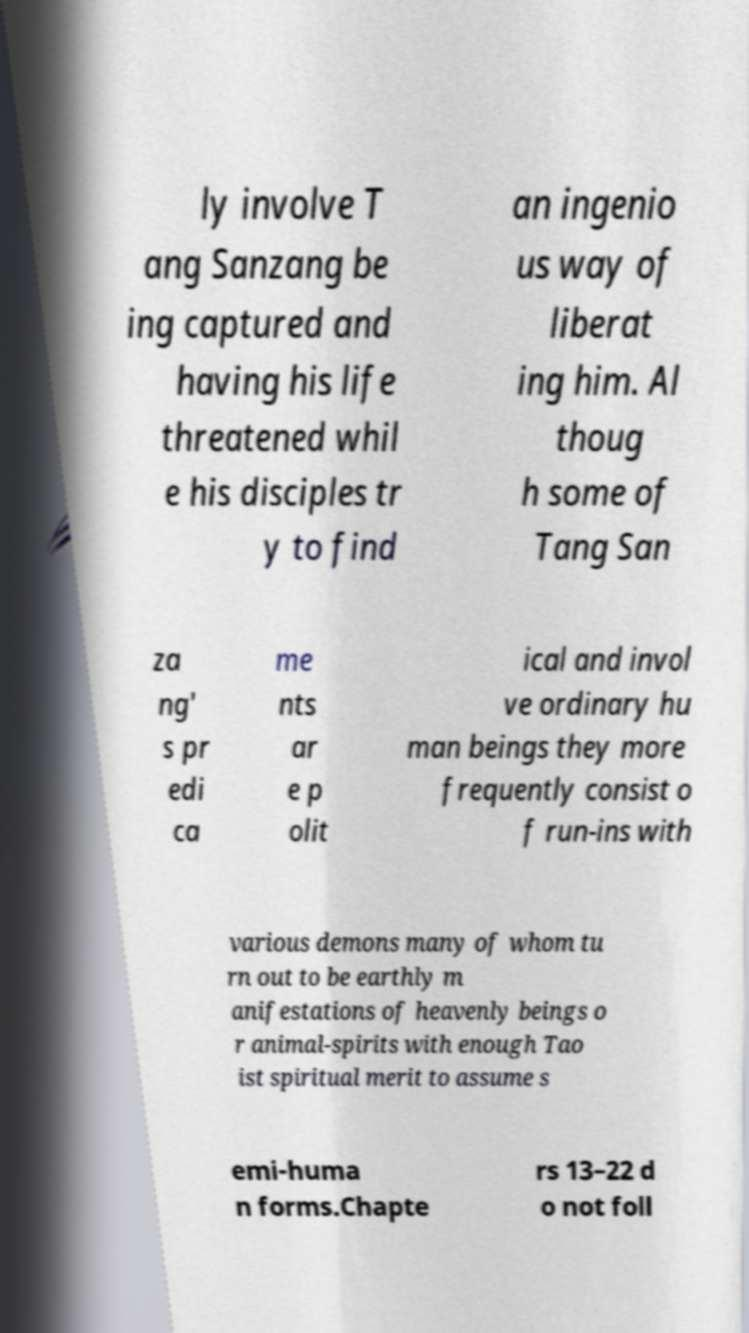Could you assist in decoding the text presented in this image and type it out clearly? ly involve T ang Sanzang be ing captured and having his life threatened whil e his disciples tr y to find an ingenio us way of liberat ing him. Al thoug h some of Tang San za ng' s pr edi ca me nts ar e p olit ical and invol ve ordinary hu man beings they more frequently consist o f run-ins with various demons many of whom tu rn out to be earthly m anifestations of heavenly beings o r animal-spirits with enough Tao ist spiritual merit to assume s emi-huma n forms.Chapte rs 13–22 d o not foll 